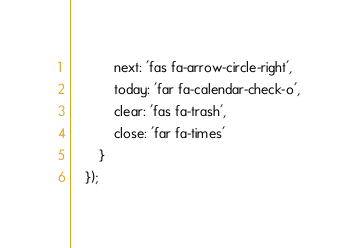Convert code to text. <code><loc_0><loc_0><loc_500><loc_500><_JavaScript_>            next: 'fas fa-arrow-circle-right',
            today: 'far fa-calendar-check-o',
            clear: 'fas fa-trash',
            close: 'far fa-times'
        }
    });</code> 